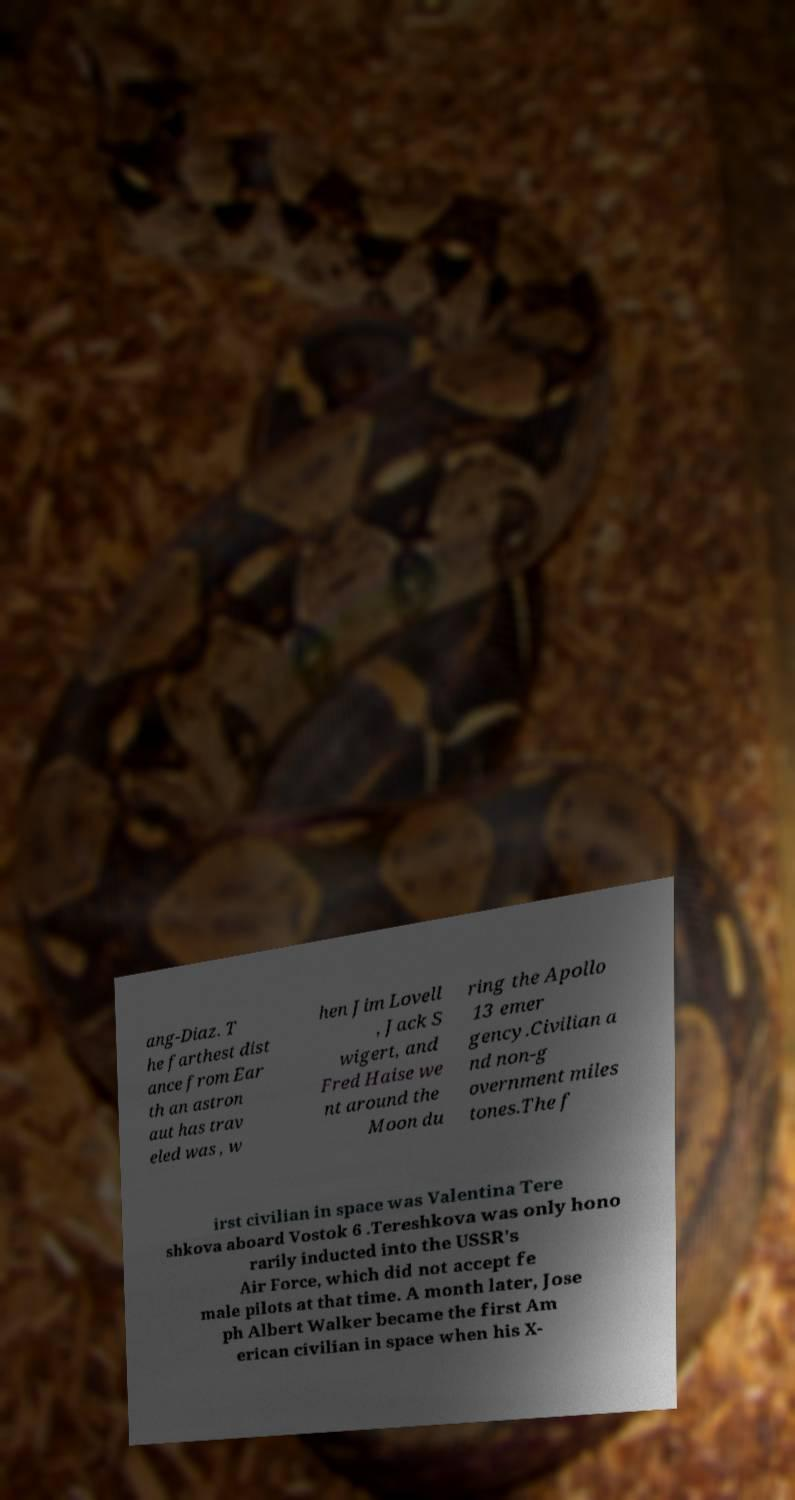Could you assist in decoding the text presented in this image and type it out clearly? ang-Diaz. T he farthest dist ance from Ear th an astron aut has trav eled was , w hen Jim Lovell , Jack S wigert, and Fred Haise we nt around the Moon du ring the Apollo 13 emer gency.Civilian a nd non-g overnment miles tones.The f irst civilian in space was Valentina Tere shkova aboard Vostok 6 .Tereshkova was only hono rarily inducted into the USSR's Air Force, which did not accept fe male pilots at that time. A month later, Jose ph Albert Walker became the first Am erican civilian in space when his X- 